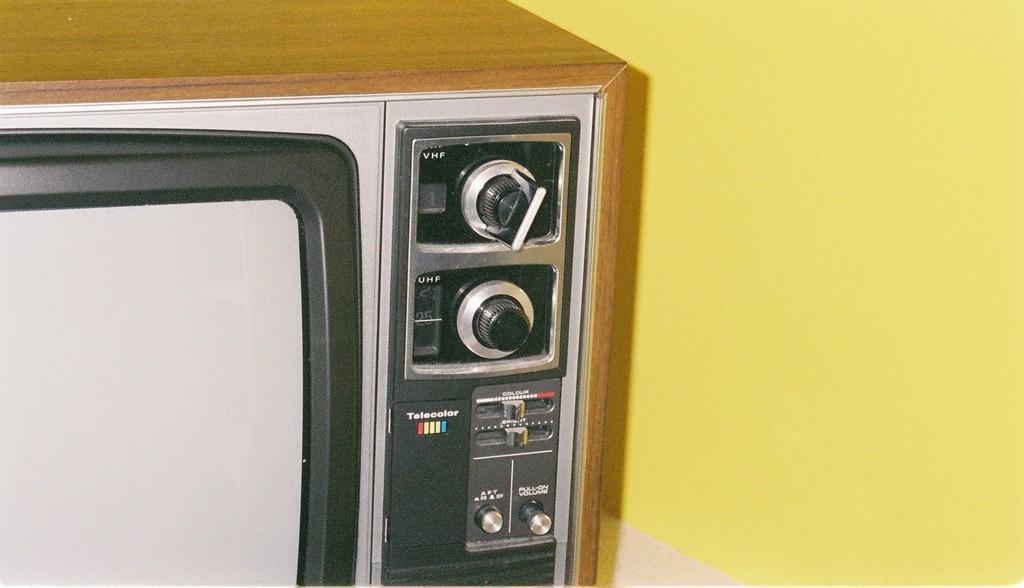What are the 3 letters next to the top knob?
Provide a short and direct response. Vhf. 